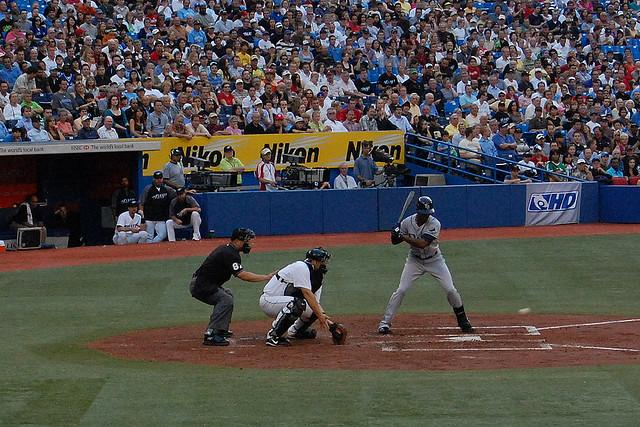What kind of product does the sponsor with the yellow background offer?

Choices:
A) phones
B) computers
C) musical instruments
D) cameras cameras 